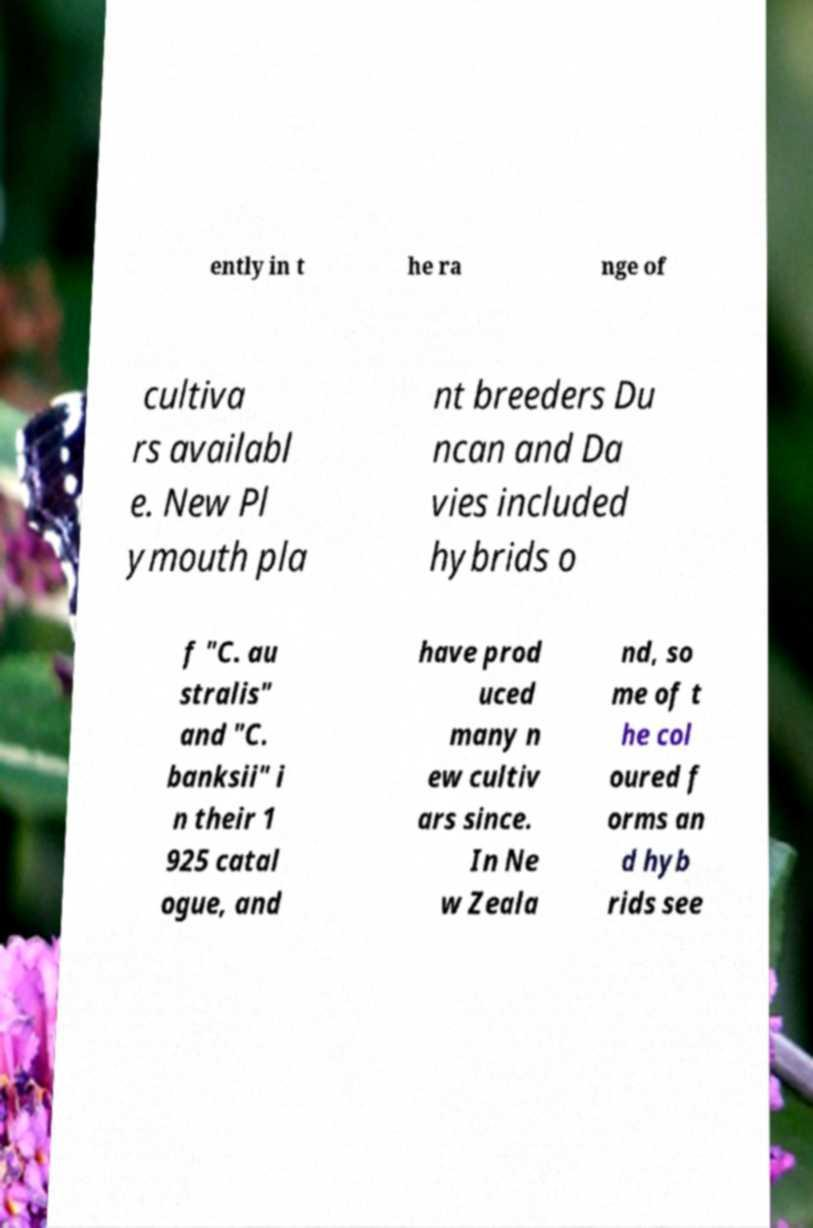There's text embedded in this image that I need extracted. Can you transcribe it verbatim? ently in t he ra nge of cultiva rs availabl e. New Pl ymouth pla nt breeders Du ncan and Da vies included hybrids o f "C. au stralis" and "C. banksii" i n their 1 925 catal ogue, and have prod uced many n ew cultiv ars since. In Ne w Zeala nd, so me of t he col oured f orms an d hyb rids see 